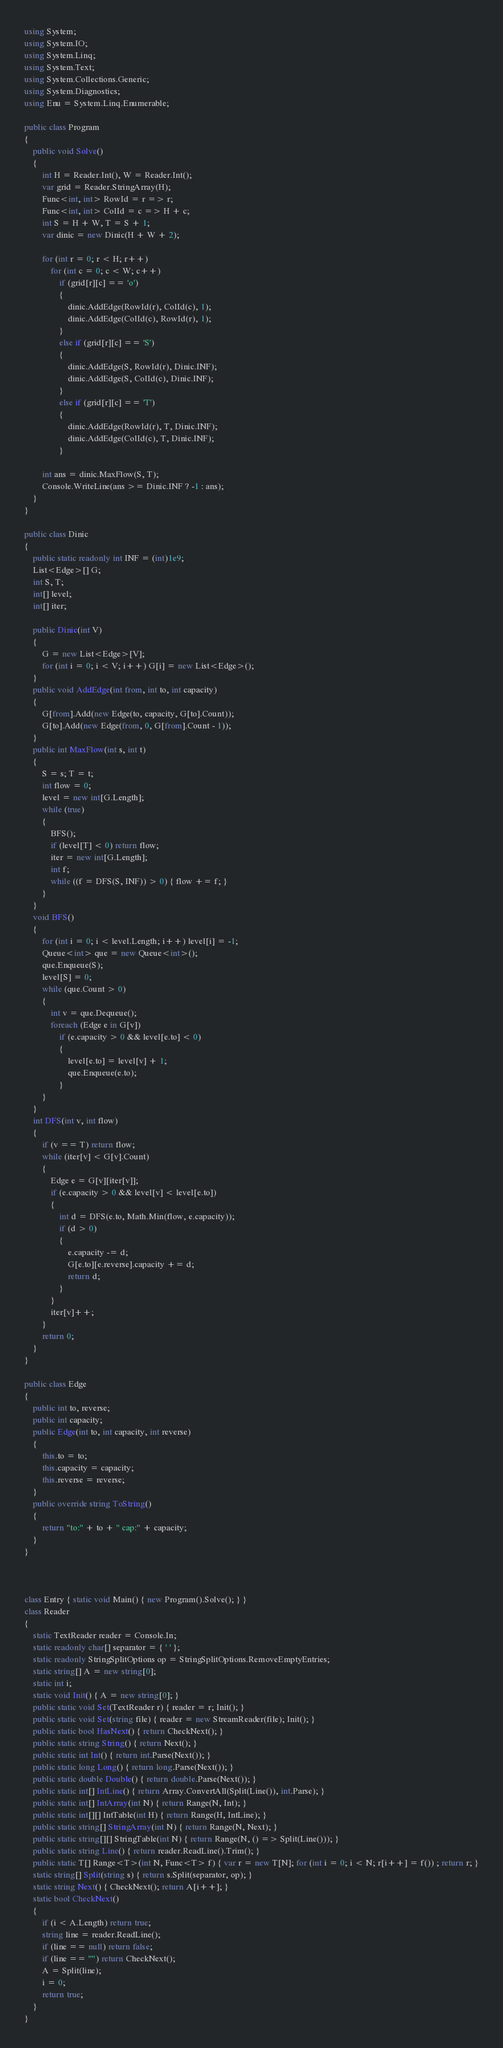<code> <loc_0><loc_0><loc_500><loc_500><_C#_>using System;
using System.IO;
using System.Linq;
using System.Text;
using System.Collections.Generic;
using System.Diagnostics;
using Enu = System.Linq.Enumerable;

public class Program
{
    public void Solve()
    {
        int H = Reader.Int(), W = Reader.Int();
        var grid = Reader.StringArray(H);
        Func<int, int> RowId = r => r;
        Func<int, int> ColId = c => H + c;
        int S = H + W, T = S + 1;
        var dinic = new Dinic(H + W + 2);

        for (int r = 0; r < H; r++)
            for (int c = 0; c < W; c++)
                if (grid[r][c] == 'o')
                {
                    dinic.AddEdge(RowId(r), ColId(c), 1);
                    dinic.AddEdge(ColId(c), RowId(r), 1);
                }
                else if (grid[r][c] == 'S')
                {
                    dinic.AddEdge(S, RowId(r), Dinic.INF);
                    dinic.AddEdge(S, ColId(c), Dinic.INF);
                }
                else if (grid[r][c] == 'T')
                {
                    dinic.AddEdge(RowId(r), T, Dinic.INF);
                    dinic.AddEdge(ColId(c), T, Dinic.INF);
                }

        int ans = dinic.MaxFlow(S, T);
        Console.WriteLine(ans >= Dinic.INF ? -1 : ans);
    }
}

public class Dinic
{
    public static readonly int INF = (int)1e9;
    List<Edge>[] G;
    int S, T;
    int[] level;
    int[] iter;

    public Dinic(int V)
    {
        G = new List<Edge>[V];
        for (int i = 0; i < V; i++) G[i] = new List<Edge>();
    }
    public void AddEdge(int from, int to, int capacity)
    {
        G[from].Add(new Edge(to, capacity, G[to].Count));
        G[to].Add(new Edge(from, 0, G[from].Count - 1));
    }
    public int MaxFlow(int s, int t)
    {
        S = s; T = t;
        int flow = 0;
        level = new int[G.Length];
        while (true)
        {
            BFS();
            if (level[T] < 0) return flow;
            iter = new int[G.Length];
            int f;
            while ((f = DFS(S, INF)) > 0) { flow += f; }
        }
    }
    void BFS()
    {
        for (int i = 0; i < level.Length; i++) level[i] = -1;
        Queue<int> que = new Queue<int>();
        que.Enqueue(S);
        level[S] = 0;
        while (que.Count > 0)
        {
            int v = que.Dequeue();
            foreach (Edge e in G[v])
                if (e.capacity > 0 && level[e.to] < 0)
                {
                    level[e.to] = level[v] + 1;
                    que.Enqueue(e.to);
                }
        }
    }
    int DFS(int v, int flow)
    {
        if (v == T) return flow;
        while (iter[v] < G[v].Count)
        {
            Edge e = G[v][iter[v]];
            if (e.capacity > 0 && level[v] < level[e.to])
            {
                int d = DFS(e.to, Math.Min(flow, e.capacity));
                if (d > 0)
                {
                    e.capacity -= d;
                    G[e.to][e.reverse].capacity += d;
                    return d;
                }
            }
            iter[v]++;
        }
        return 0;
    }
}

public class Edge
{
    public int to, reverse;
    public int capacity;
    public Edge(int to, int capacity, int reverse)
    {
        this.to = to;
        this.capacity = capacity;
        this.reverse = reverse;
    }
    public override string ToString()
    {
        return "to:" + to + " cap:" + capacity;
    }
}



class Entry { static void Main() { new Program().Solve(); } }
class Reader
{
    static TextReader reader = Console.In;
    static readonly char[] separator = { ' ' };
    static readonly StringSplitOptions op = StringSplitOptions.RemoveEmptyEntries;
    static string[] A = new string[0];
    static int i;
    static void Init() { A = new string[0]; }
    public static void Set(TextReader r) { reader = r; Init(); }
    public static void Set(string file) { reader = new StreamReader(file); Init(); }
    public static bool HasNext() { return CheckNext(); }
    public static string String() { return Next(); }
    public static int Int() { return int.Parse(Next()); }
    public static long Long() { return long.Parse(Next()); }
    public static double Double() { return double.Parse(Next()); }
    public static int[] IntLine() { return Array.ConvertAll(Split(Line()), int.Parse); }
    public static int[] IntArray(int N) { return Range(N, Int); }
    public static int[][] IntTable(int H) { return Range(H, IntLine); }
    public static string[] StringArray(int N) { return Range(N, Next); }
    public static string[][] StringTable(int N) { return Range(N, () => Split(Line())); }
    public static string Line() { return reader.ReadLine().Trim(); }
    public static T[] Range<T>(int N, Func<T> f) { var r = new T[N]; for (int i = 0; i < N; r[i++] = f()) ; return r; }
    static string[] Split(string s) { return s.Split(separator, op); }
    static string Next() { CheckNext(); return A[i++]; }
    static bool CheckNext()
    {
        if (i < A.Length) return true;
        string line = reader.ReadLine();
        if (line == null) return false;
        if (line == "") return CheckNext();
        A = Split(line);
        i = 0;
        return true;
    }
}</code> 